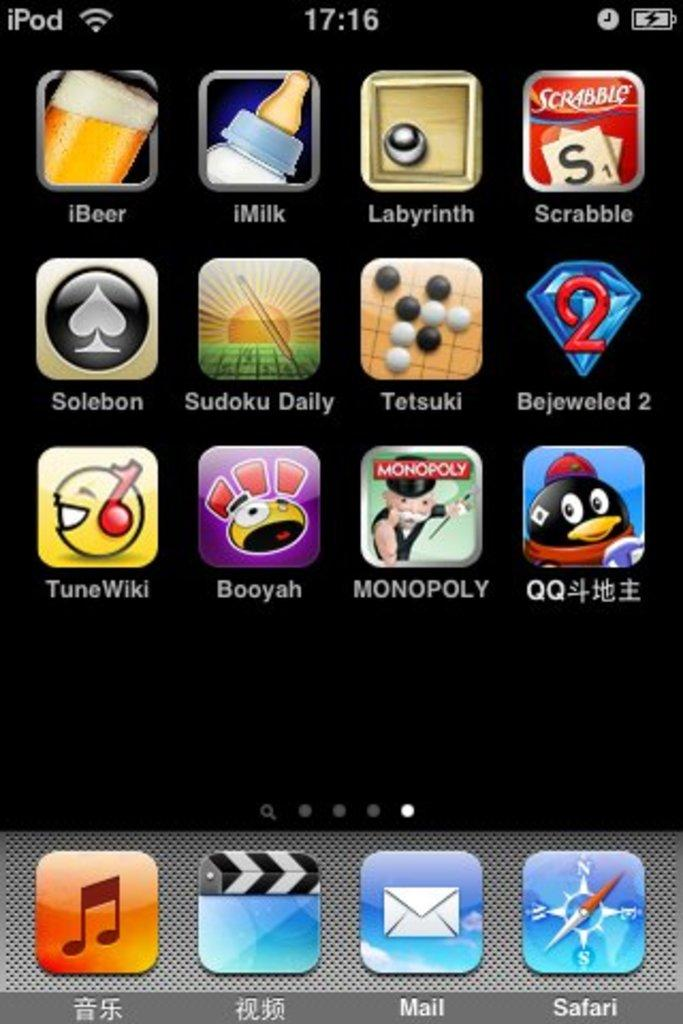<image>
Render a clear and concise summary of the photo. an iPod screen displaying multiple apps in English and Chinese 